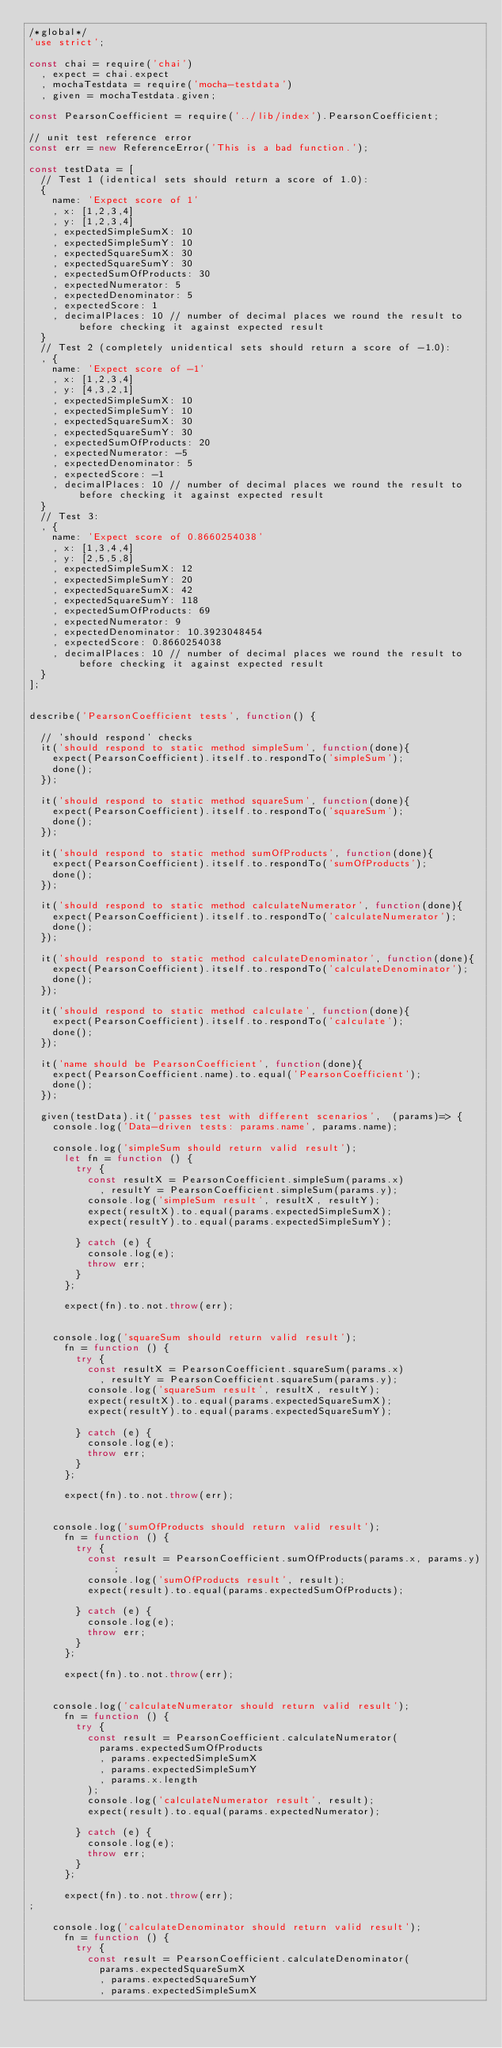Convert code to text. <code><loc_0><loc_0><loc_500><loc_500><_JavaScript_>/*global*/
'use strict';

const chai = require('chai')
	, expect = chai.expect
	, mochaTestdata = require('mocha-testdata')
	, given = mochaTestdata.given;
	
const PearsonCoefficient = require('../lib/index').PearsonCoefficient;

// unit test reference error
const err = new ReferenceError('This is a bad function.');

const testData = [
	// Test 1 (identical sets should return a score of 1.0):
	{
		name: 'Expect score of 1'
		, x: [1,2,3,4]
		, y: [1,2,3,4]
		, expectedSimpleSumX: 10
		, expectedSimpleSumY: 10
		, expectedSquareSumX: 30
		, expectedSquareSumY: 30
		, expectedSumOfProducts: 30
		, expectedNumerator: 5
		, expectedDenominator: 5
		, expectedScore: 1
		, decimalPlaces: 10 // number of decimal places we round the result to before checking it against expected result
	}
	// Test 2 (completely unidentical sets should return a score of -1.0):
	, {
		name: 'Expect score of -1'
		, x: [1,2,3,4]
		, y: [4,3,2,1]
		, expectedSimpleSumX: 10
		, expectedSimpleSumY: 10
		, expectedSquareSumX: 30
		, expectedSquareSumY: 30
		, expectedSumOfProducts: 20
		, expectedNumerator: -5
		, expectedDenominator: 5
		, expectedScore: -1
		, decimalPlaces: 10 // number of decimal places we round the result to before checking it against expected result
	}
	// Test 3:
	, {
		name: 'Expect score of 0.8660254038'
		, x: [1,3,4,4]
		, y: [2,5,5,8]
		, expectedSimpleSumX: 12
		, expectedSimpleSumY: 20
		, expectedSquareSumX: 42
		, expectedSquareSumY: 118
		, expectedSumOfProducts: 69
		, expectedNumerator: 9
		, expectedDenominator: 10.3923048454
		, expectedScore: 0.8660254038
		, decimalPlaces: 10 // number of decimal places we round the result to before checking it against expected result
	}
];


describe('PearsonCoefficient tests', function() {

	// 'should respond' checks
	it('should respond to static method simpleSum', function(done){
		expect(PearsonCoefficient).itself.to.respondTo('simpleSum');
		done();
	});
	
	it('should respond to static method squareSum', function(done){
		expect(PearsonCoefficient).itself.to.respondTo('squareSum');
		done();
	});
	
	it('should respond to static method sumOfProducts', function(done){
		expect(PearsonCoefficient).itself.to.respondTo('sumOfProducts');
		done();
	});
	
	it('should respond to static method calculateNumerator', function(done){
		expect(PearsonCoefficient).itself.to.respondTo('calculateNumerator');
		done();
	});
	
	it('should respond to static method calculateDenominator', function(done){
		expect(PearsonCoefficient).itself.to.respondTo('calculateDenominator');
		done();
	});
	
	it('should respond to static method calculate', function(done){
		expect(PearsonCoefficient).itself.to.respondTo('calculate');
		done();
	});
	
	it('name should be PearsonCoefficient', function(done){
		expect(PearsonCoefficient.name).to.equal('PearsonCoefficient');
		done();
	});
	
	given(testData).it('passes test with different scenarios',  (params)=> {
		console.log('Data-driven tests: params.name', params.name);
		
		console.log('simpleSum should return valid result');
			let fn = function () { 
				try {
					const resultX = PearsonCoefficient.simpleSum(params.x)
						, resultY = PearsonCoefficient.simpleSum(params.y);
					console.log('simpleSum result', resultX, resultY);
					expect(resultX).to.equal(params.expectedSimpleSumX);
					expect(resultY).to.equal(params.expectedSimpleSumY);

				} catch (e) {
					console.log(e);
					throw err;
				}
			};
			
			expect(fn).to.not.throw(err);


		console.log('squareSum should return valid result');
			fn = function () { 
				try {
					const resultX = PearsonCoefficient.squareSum(params.x)
						, resultY = PearsonCoefficient.squareSum(params.y);
					console.log('squareSum result', resultX, resultY);
					expect(resultX).to.equal(params.expectedSquareSumX);
					expect(resultY).to.equal(params.expectedSquareSumY);

				} catch (e) {
					console.log(e);
					throw err;
				}
			};
			
			expect(fn).to.not.throw(err);


		console.log('sumOfProducts should return valid result');
			fn = function () { 
				try {
					const result = PearsonCoefficient.sumOfProducts(params.x, params.y);
					console.log('sumOfProducts result', result);
					expect(result).to.equal(params.expectedSumOfProducts);

				} catch (e) {
					console.log(e);
					throw err;
				}
			};
			
			expect(fn).to.not.throw(err);
		
		
		console.log('calculateNumerator should return valid result');
			fn = function () { 
				try {
					const result = PearsonCoefficient.calculateNumerator(
						params.expectedSumOfProducts
						, params.expectedSimpleSumX
						, params.expectedSimpleSumY
						, params.x.length
					);
					console.log('calculateNumerator result', result);
					expect(result).to.equal(params.expectedNumerator);

				} catch (e) {
					console.log(e);
					throw err;
				}
			};
			
			expect(fn).to.not.throw(err);
;

		console.log('calculateDenominator should return valid result');
			fn = function () { 
				try {
					const result = PearsonCoefficient.calculateDenominator(
						params.expectedSquareSumX
						, params.expectedSquareSumY
						, params.expectedSimpleSumX</code> 